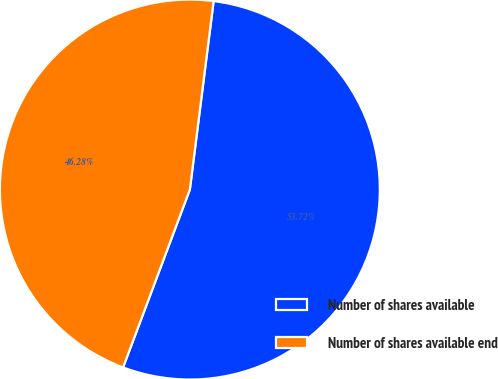Convert chart. <chart><loc_0><loc_0><loc_500><loc_500><pie_chart><fcel>Number of shares available<fcel>Number of shares available end<nl><fcel>53.72%<fcel>46.28%<nl></chart> 